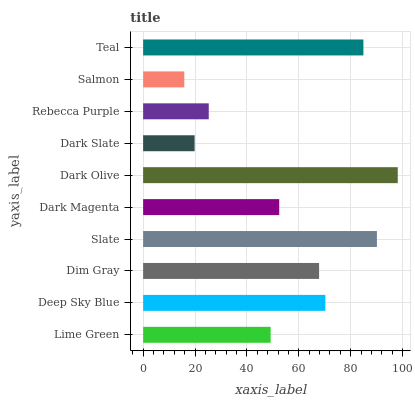Is Salmon the minimum?
Answer yes or no. Yes. Is Dark Olive the maximum?
Answer yes or no. Yes. Is Deep Sky Blue the minimum?
Answer yes or no. No. Is Deep Sky Blue the maximum?
Answer yes or no. No. Is Deep Sky Blue greater than Lime Green?
Answer yes or no. Yes. Is Lime Green less than Deep Sky Blue?
Answer yes or no. Yes. Is Lime Green greater than Deep Sky Blue?
Answer yes or no. No. Is Deep Sky Blue less than Lime Green?
Answer yes or no. No. Is Dim Gray the high median?
Answer yes or no. Yes. Is Dark Magenta the low median?
Answer yes or no. Yes. Is Teal the high median?
Answer yes or no. No. Is Dark Slate the low median?
Answer yes or no. No. 